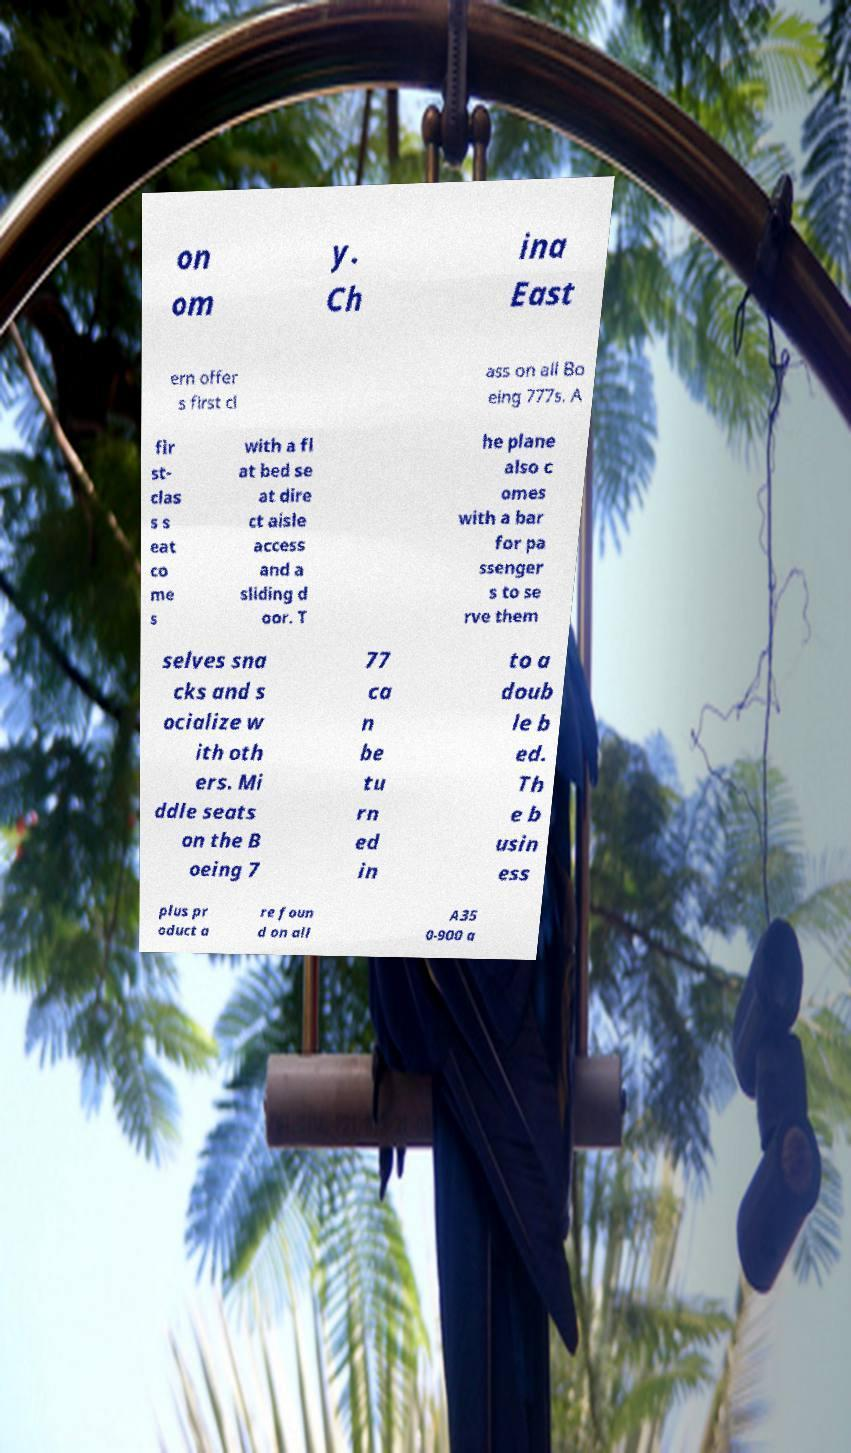Please identify and transcribe the text found in this image. on om y. Ch ina East ern offer s first cl ass on all Bo eing 777s. A fir st- clas s s eat co me s with a fl at bed se at dire ct aisle access and a sliding d oor. T he plane also c omes with a bar for pa ssenger s to se rve them selves sna cks and s ocialize w ith oth ers. Mi ddle seats on the B oeing 7 77 ca n be tu rn ed in to a doub le b ed. Th e b usin ess plus pr oduct a re foun d on all A35 0-900 a 